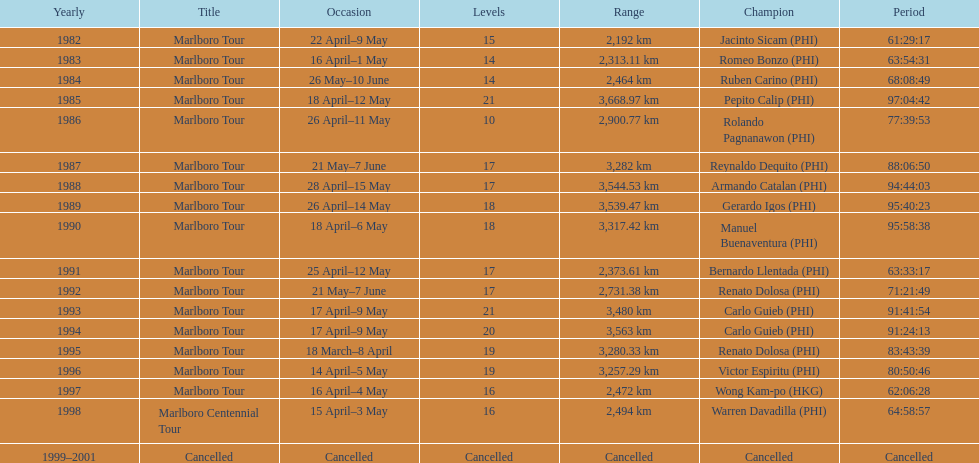How many stages was the 1982 marlboro tour? 15. 